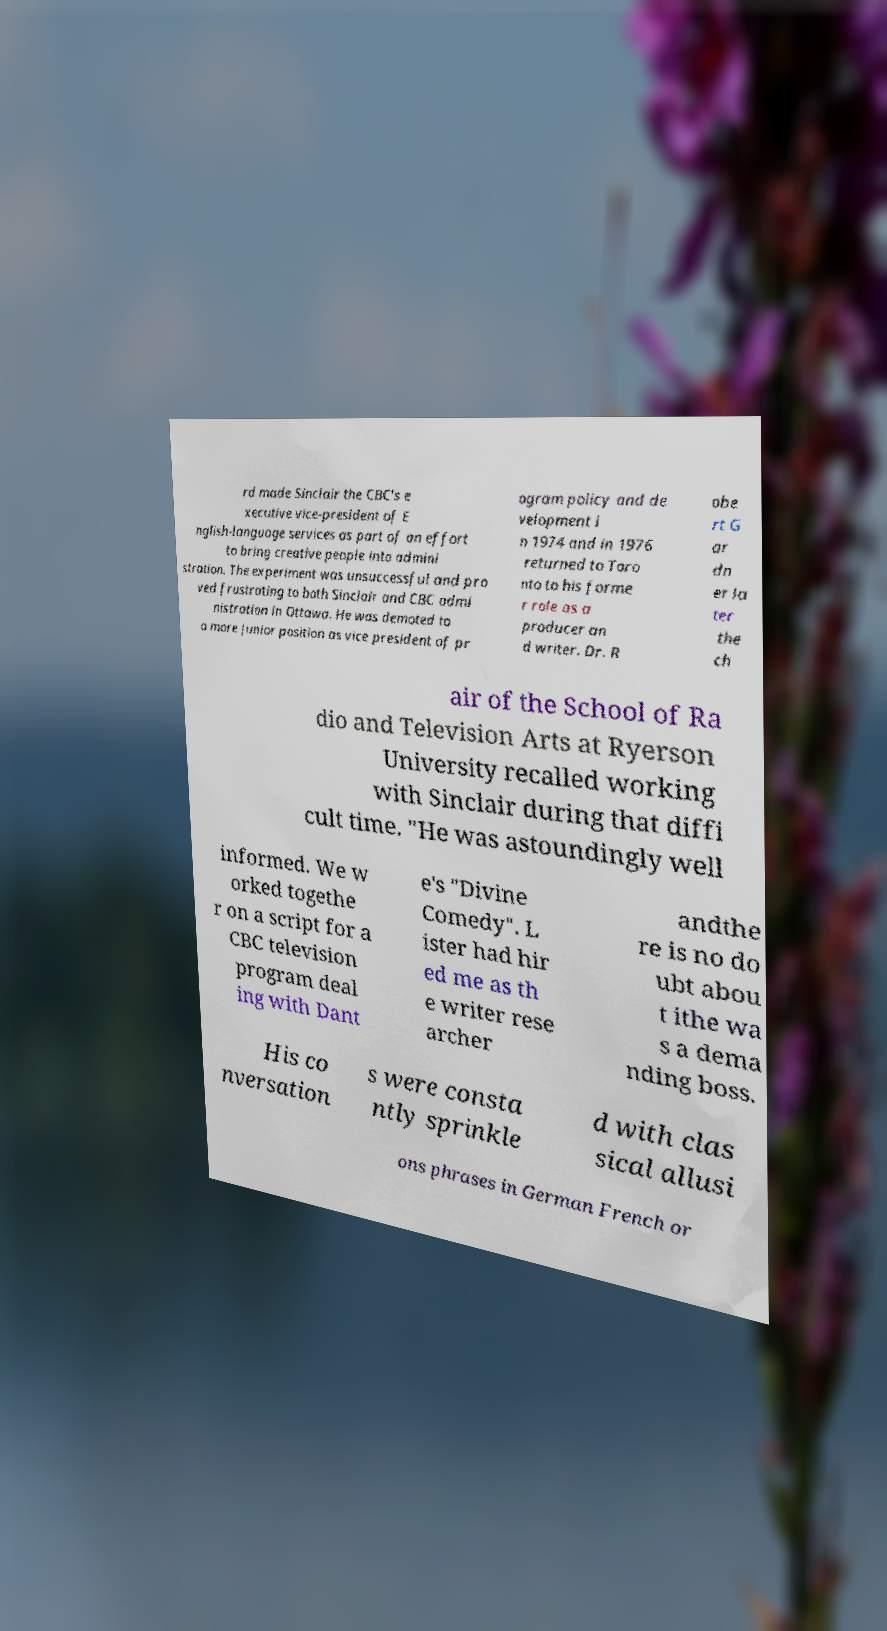Could you assist in decoding the text presented in this image and type it out clearly? rd made Sinclair the CBC's e xecutive vice-president of E nglish-language services as part of an effort to bring creative people into admini stration. The experiment was unsuccessful and pro ved frustrating to both Sinclair and CBC admi nistration in Ottawa. He was demoted to a more junior position as vice president of pr ogram policy and de velopment i n 1974 and in 1976 returned to Toro nto to his forme r role as a producer an d writer. Dr. R obe rt G ar dn er la ter the ch air of the School of Ra dio and Television Arts at Ryerson University recalled working with Sinclair during that diffi cult time. "He was astoundingly well informed. We w orked togethe r on a script for a CBC television program deal ing with Dant e's "Divine Comedy". L ister had hir ed me as th e writer rese archer andthe re is no do ubt abou t ithe wa s a dema nding boss. His co nversation s were consta ntly sprinkle d with clas sical allusi ons phrases in German French or 